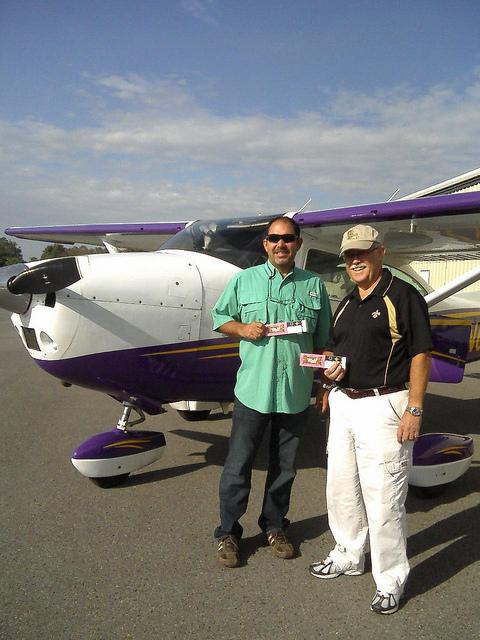What are these men displaying? Please explain your reasoning. pilots license. The men are showing off their pilots' licenses. 